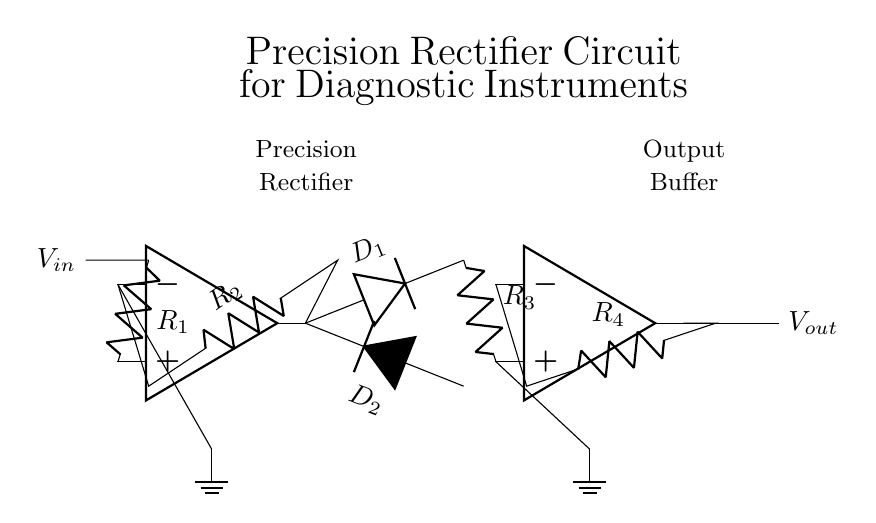What type of circuit is depicted in the diagram? The circuit is a precision rectifier, which is designed to accurately convert an AC input voltage into a DC output voltage with minimal distortion. This is indicated by the label on the circuit and the presence of operational amplifiers.
Answer: Precision rectifier How many operational amplifiers are used in this circuit? There are two operational amplifiers present in the circuit, which are easily identifiable at the left and right sides of the diagram. Each op-amp is clearly labeled and drawn in a standard op-amp symbol.
Answer: Two What is the role of the diodes in this precision rectifier circuit? The diodes in this circuit (D1 and D2) are used to allow current to flow in one direction only, ensuring that the output voltage reflects the absolute value of the input voltage. This rectification process is vital for converting AC signals into DC.
Answer: Rectification What resistors are present in the feedback loop of the first op-amp? The feedback loop of the first operational amplifier includes resistors R2 and R1. R1 connects the input signal to the non-inverting terminal, and R2 completes the feedback path to the inverting terminal.
Answer: R1 and R2 What is the purpose of the output buffer in this circuit? The output buffer (the second operational amplifier) provides impedance matching and isolates the rectified output from any load that may be connected. This ensures that the output voltage remains stable and unaffected by variations in load.
Answer: Impedance matching What kind of input signal is this circuit designed to process? This precision rectifier circuit is designed to process analog AC input signals, which can be converted to a correctly polarized DC output, suitable for further signal processing in diagnostic instruments.
Answer: AC signal What is the output voltage relative to the input voltage in an ideal precision rectifier? In an ideal precision rectifier circuit, the output voltage will be the absolute value of the input voltage when the input is positive, effectively capturing both positive and negative input signals.
Answer: Absolute value of Vin 